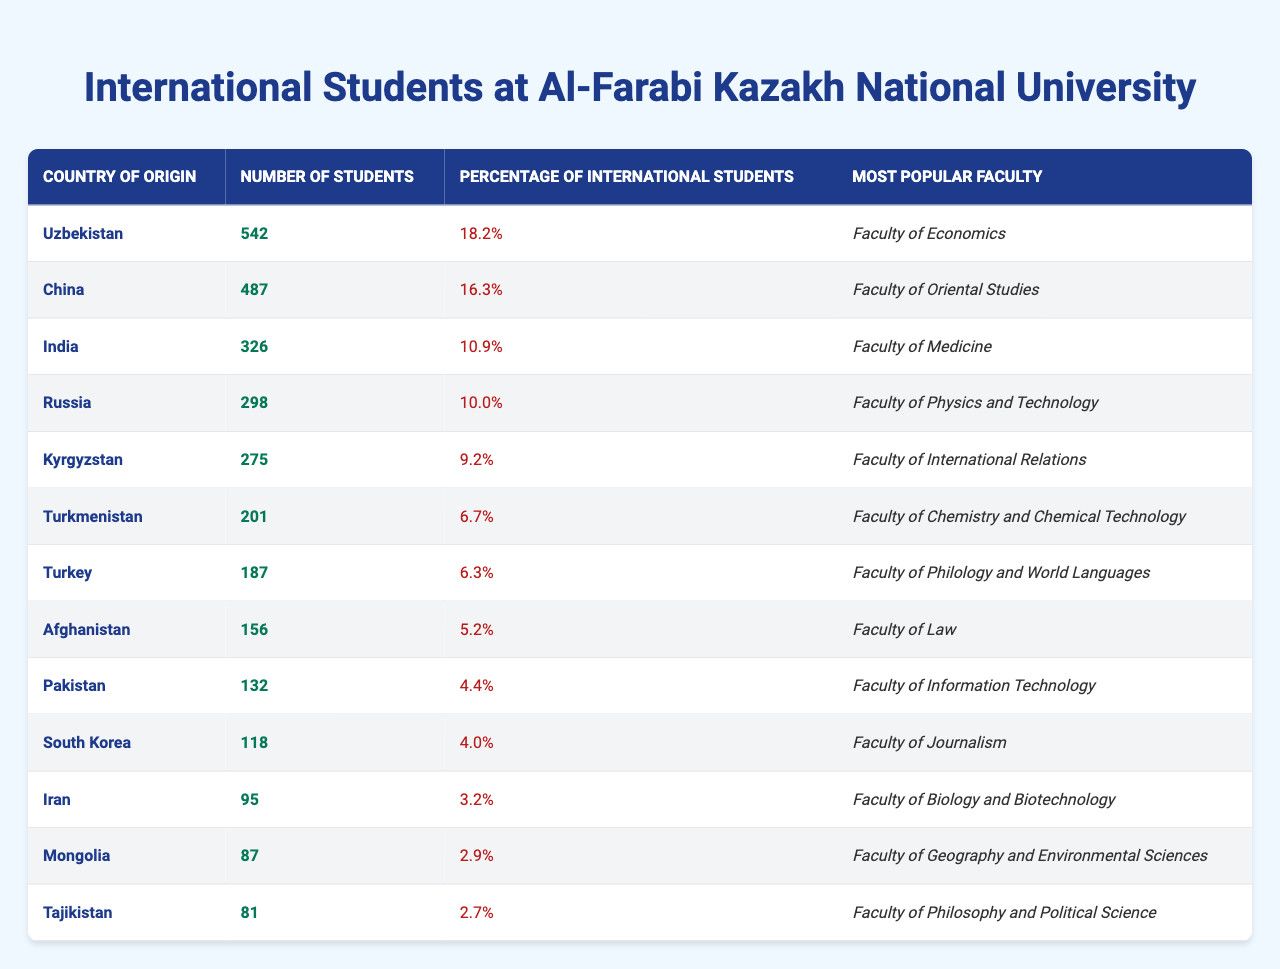What is the country with the highest number of international students at Al-Farabi Kazakh National University? By looking at the "Number of Students" column, Uzbekistan has the highest number listed, which is 542.
Answer: Uzbekistan What percentage of international students at Al-Farabi Kazakh National University come from China? According to the "Percentage of International Students" column, China accounts for 16.3% of the international students.
Answer: 16.3% What is the most popular faculty among students from Afghanistan? The "Most Popular Faculty" column shows that the Faculty of Law is the most popular among Afghan students.
Answer: Faculty of Law How many students from Turkmenistan study at Al-Farabi Kazakh National University? The "Number of Students" column indicates that there are 201 students from Turkmenistan.
Answer: 201 Which country has a lower number of international students: Kyrgyzstan or Pakistan? Kyrgyzstan has 275 students and Pakistan has 132 students, making Pakistan the country with the lower number of international students.
Answer: Pakistan What is the total number of international students from the top three countries listed in the table? Summing the number of students from Uzbekistan (542), China (487), and India (326) gives a total of 1355 students.
Answer: 1355 Is the percentage of international students from Iran greater than 3%? The percentage listed for Iran is 3.2%, which confirms that it is indeed greater than 3%.
Answer: Yes Which faculty is the most popular for students from Turkey? According to the "Most Popular Faculty" column, the Faculty of Philology and World Languages is the most popular for Turkish students.
Answer: Faculty of Philology and World Languages How many students are there from Mongolia compared to Tajikistan? Mongolia has 87 students while Tajikistan has 81. Thus, Mongolia has more students than Tajikistan by 6.
Answer: Mongolia has more by 6 students What is the average percentage of international students from the top five countries? The top five countries' percentages are 18.2% (Uzbekistan), 16.3% (China), 10.9% (India), 10.0% (Russia), and 9.2% (Kyrgyzstan). The average is (18.2 + 16.3 + 10.9 + 10.0 + 9.2) / 5 = 12.92%.
Answer: 12.92% 